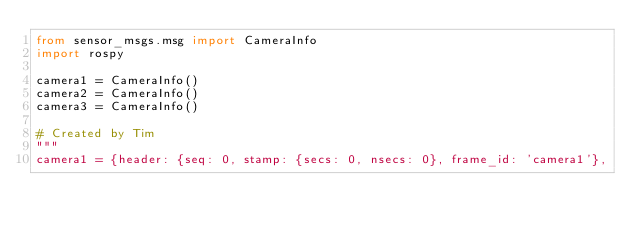Convert code to text. <code><loc_0><loc_0><loc_500><loc_500><_Python_>from sensor_msgs.msg import CameraInfo
import rospy

camera1 = CameraInfo()
camera2 = CameraInfo()
camera3 = CameraInfo()

# Created by Tim
"""
camera1 = {header: {seq: 0, stamp: {secs: 0, nsecs: 0}, frame_id: 'camera1'},</code> 